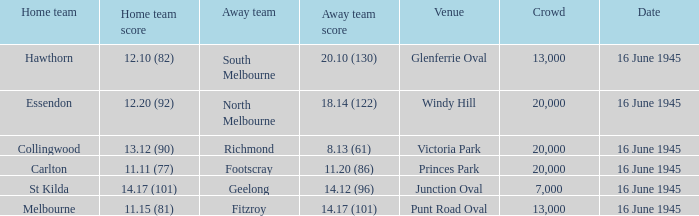What was the Home team score for the team that played South Melbourne? 12.10 (82). 